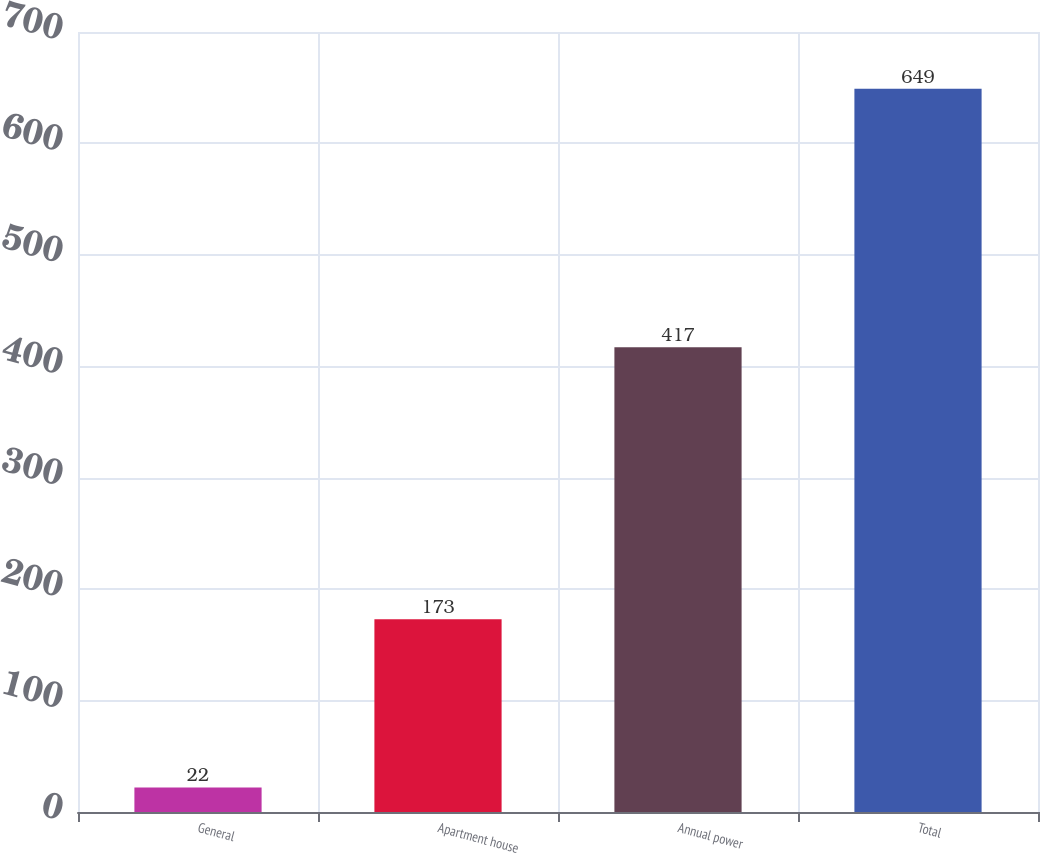Convert chart. <chart><loc_0><loc_0><loc_500><loc_500><bar_chart><fcel>General<fcel>Apartment house<fcel>Annual power<fcel>Total<nl><fcel>22<fcel>173<fcel>417<fcel>649<nl></chart> 